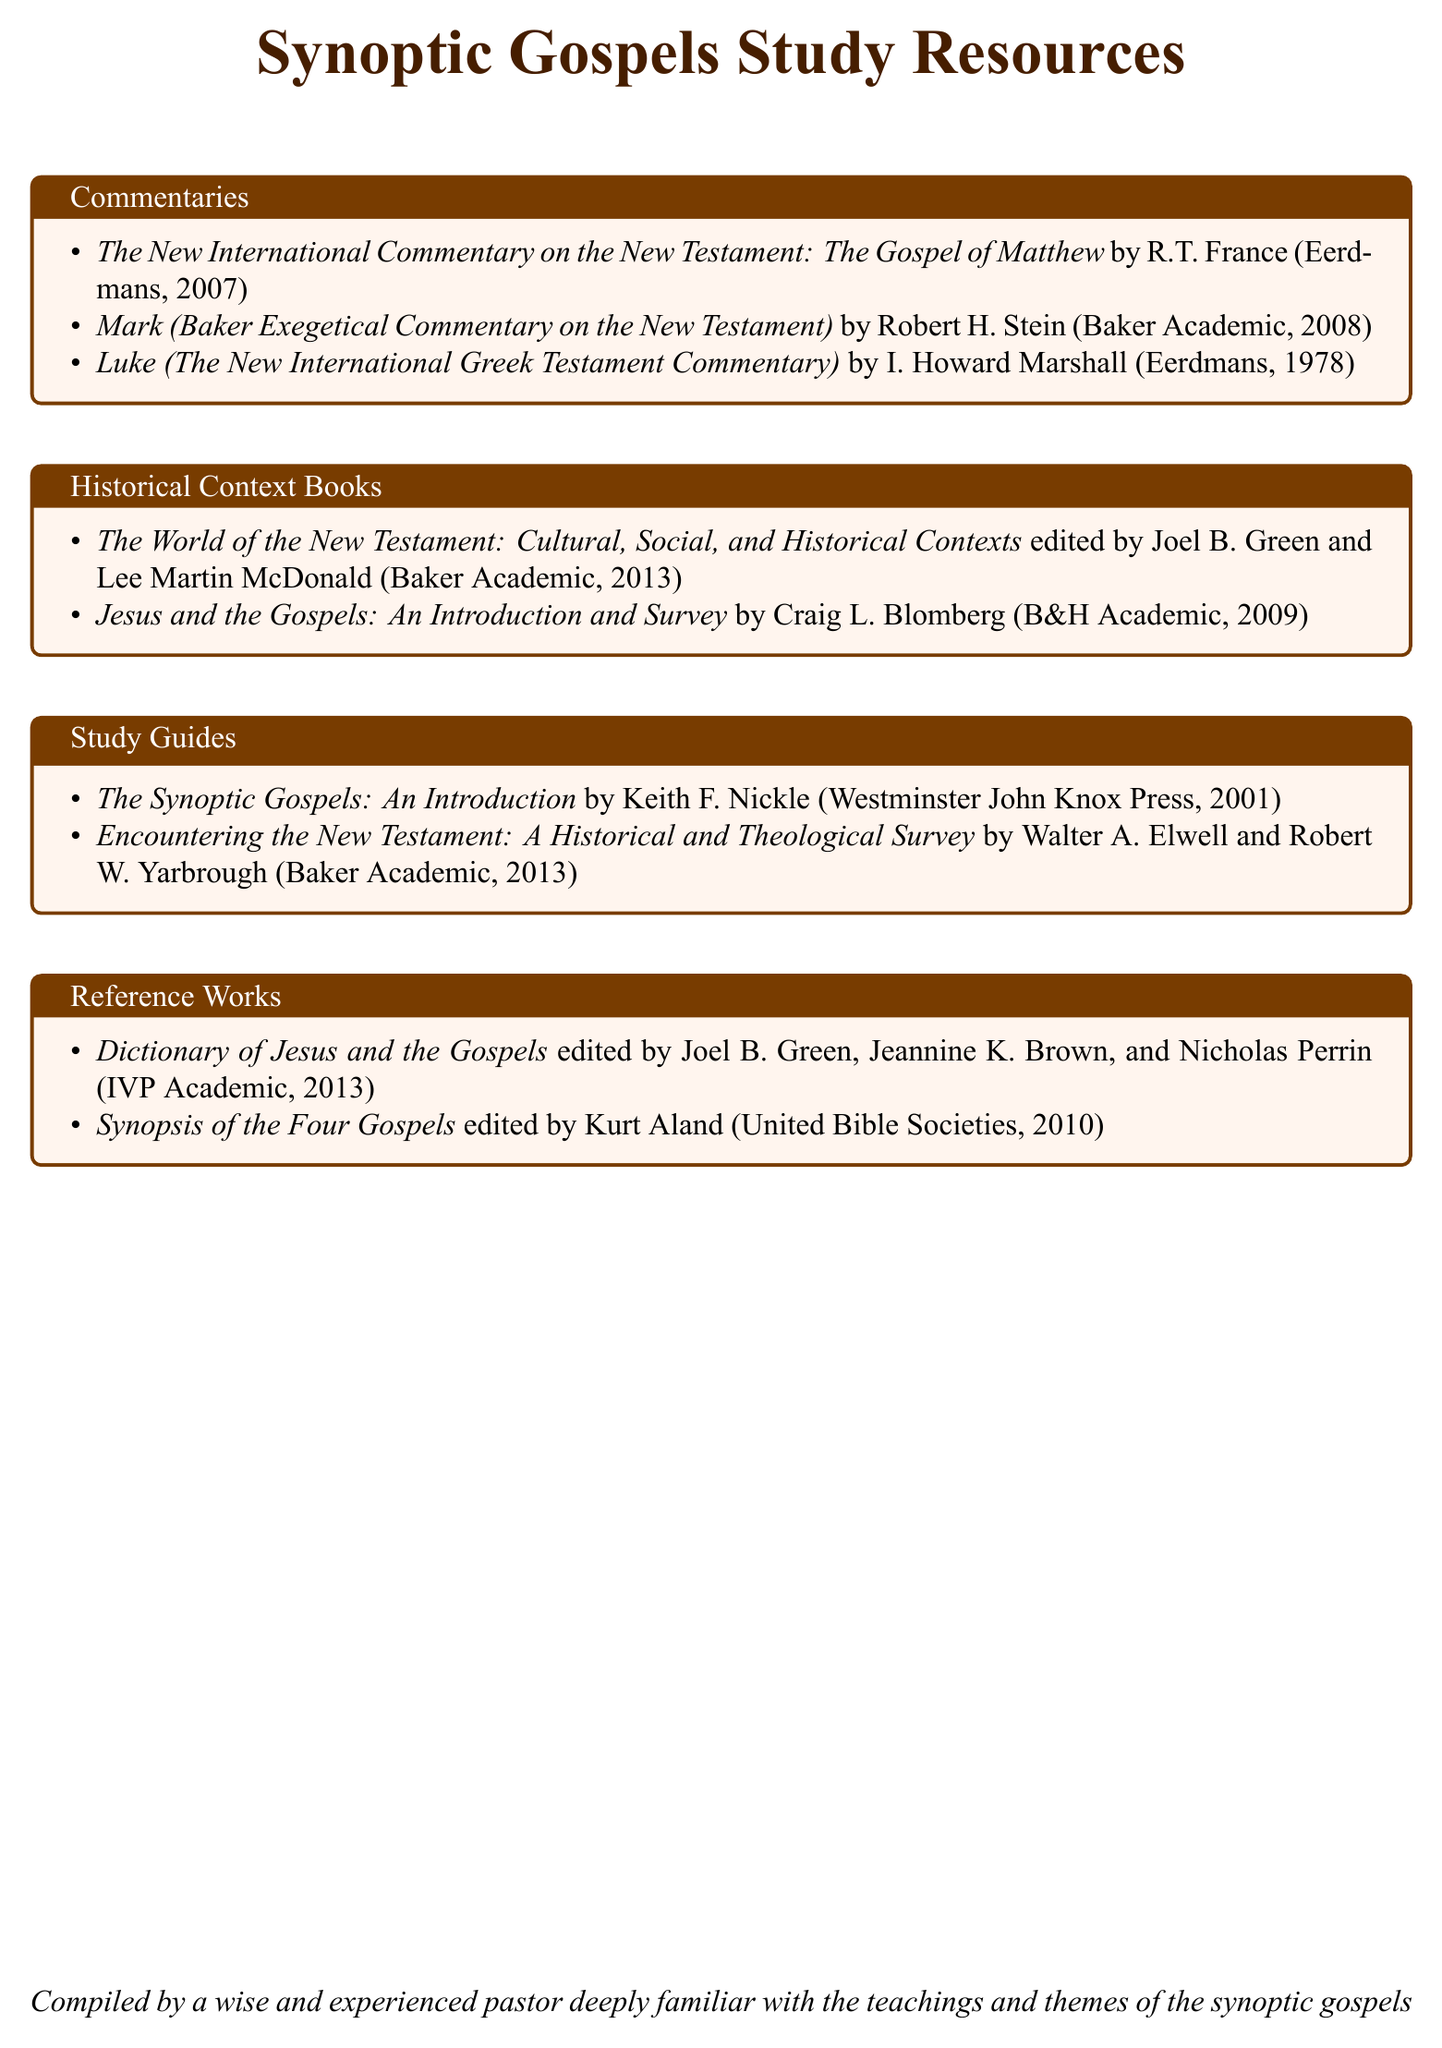What is the title of the commentary on Matthew? The title is found in the commentaries section, which lists works focusing on specific gospels.
Answer: The New International Commentary on the New Testament: The Gospel of Matthew Who is the author of the commentary on Mark? This information can be found in the commentaries section, where various authors are listed next to their works.
Answer: Robert H. Stein What year was "Luke" published? The publication year is provided with each book listed, specifically for the commentary on Luke.
Answer: 1978 How many historical context books are listed? The total can be determined by counting the items in the historical context books section of the document.
Answer: 2 What is the title of the reference work edited by Kurt Aland? This title can be found in the reference works section that includes various reference materials related to the gospels.
Answer: Synopsis of the Four Gospels Which publisher released "Encountering the New Testament"? The publisher's name is included in the study guides section along with the title and author details.
Answer: Baker Academic What type of works does the section “Commentaries” contain? This can be inferred from the section title, determining the nature of the works listed under it.
Answer: Commentaries Who are the editors of "Dictionary of Jesus and the Gospels"? This information is supplied in the reference works section where editor names are provided for specific works.
Answer: Joel B. Green, Jeannine K. Brown, and Nicholas Perrin What is the main focus of the catalog? The main focus is outlined in the title, which summarizes what the document contains.
Answer: Synoptic Gospels Study Resources 